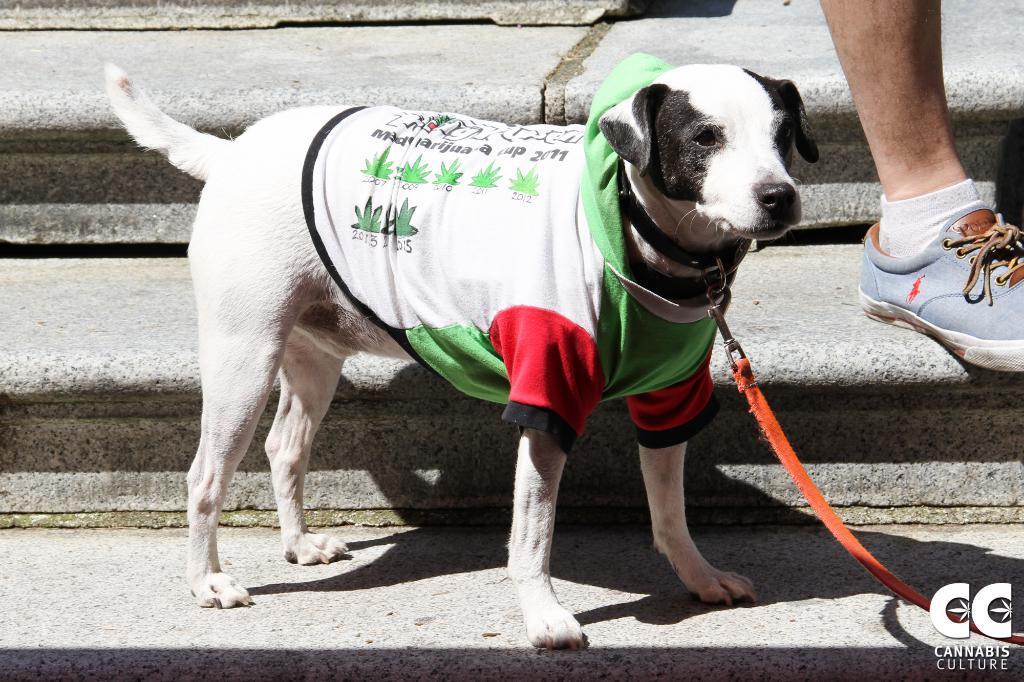In one or two sentences, can you explain what this image depicts? In this image we can see there is a dog standing on the stairs, beside the dog we can see there is a leg of a person. 